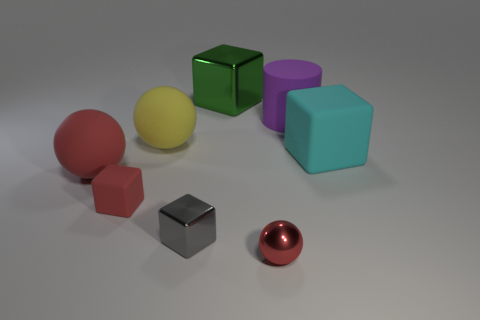What is the color of the thing that is right of the tiny gray cube and in front of the small red cube?
Provide a short and direct response. Red. How many objects are either large cyan matte cubes or big blocks?
Provide a short and direct response. 2. How many big objects are rubber spheres or balls?
Offer a very short reply. 2. Is there anything else of the same color as the large metal cube?
Make the answer very short. No. There is a object that is in front of the cylinder and right of the red metallic object; how big is it?
Your answer should be compact. Large. There is a matte block on the left side of the big purple rubber object; is it the same color as the big matte ball to the left of the big yellow object?
Give a very brief answer. Yes. What number of other things are made of the same material as the big cyan block?
Make the answer very short. 4. There is a big rubber object that is both in front of the yellow thing and on the left side of the green block; what is its shape?
Your response must be concise. Sphere. Does the small rubber block have the same color as the tiny object in front of the small gray metal block?
Offer a terse response. Yes. There is a red thing in front of the gray thing; is its size the same as the cyan object?
Give a very brief answer. No. 